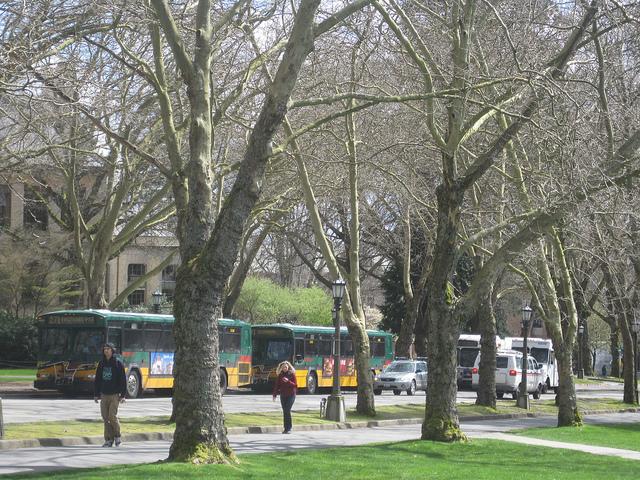Is this a one-way street?
Answer briefly. No. Could this scene inspire poetry?
Concise answer only. Yes. What color is the bus on the right side?
Concise answer only. White. Was this taken at a zoo?
Quick response, please. No. Are all the vehicles facing the same direction?
Quick response, please. No. How many trees?
Be succinct. 10. 